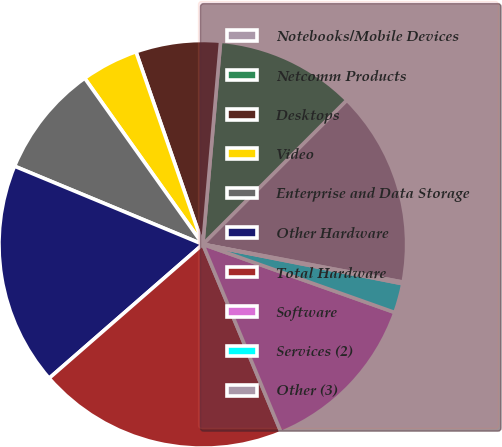Convert chart. <chart><loc_0><loc_0><loc_500><loc_500><pie_chart><fcel>Notebooks/Mobile Devices<fcel>Netcomm Products<fcel>Desktops<fcel>Video<fcel>Enterprise and Data Storage<fcel>Other Hardware<fcel>Total Hardware<fcel>Software<fcel>Services (2)<fcel>Other (3)<nl><fcel>15.48%<fcel>11.1%<fcel>6.71%<fcel>4.52%<fcel>8.9%<fcel>17.67%<fcel>19.87%<fcel>13.29%<fcel>2.33%<fcel>0.13%<nl></chart> 